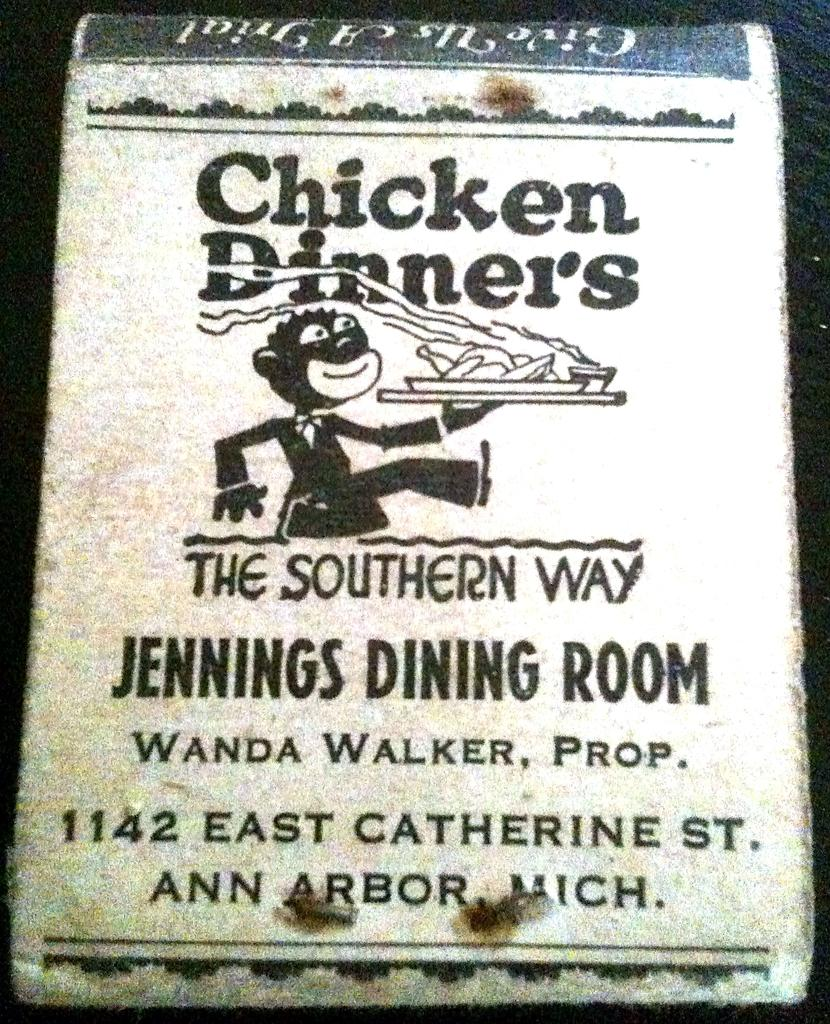<image>
Write a terse but informative summary of the picture. Sign for Chicken Dinners which is located in Ann Arbor. 